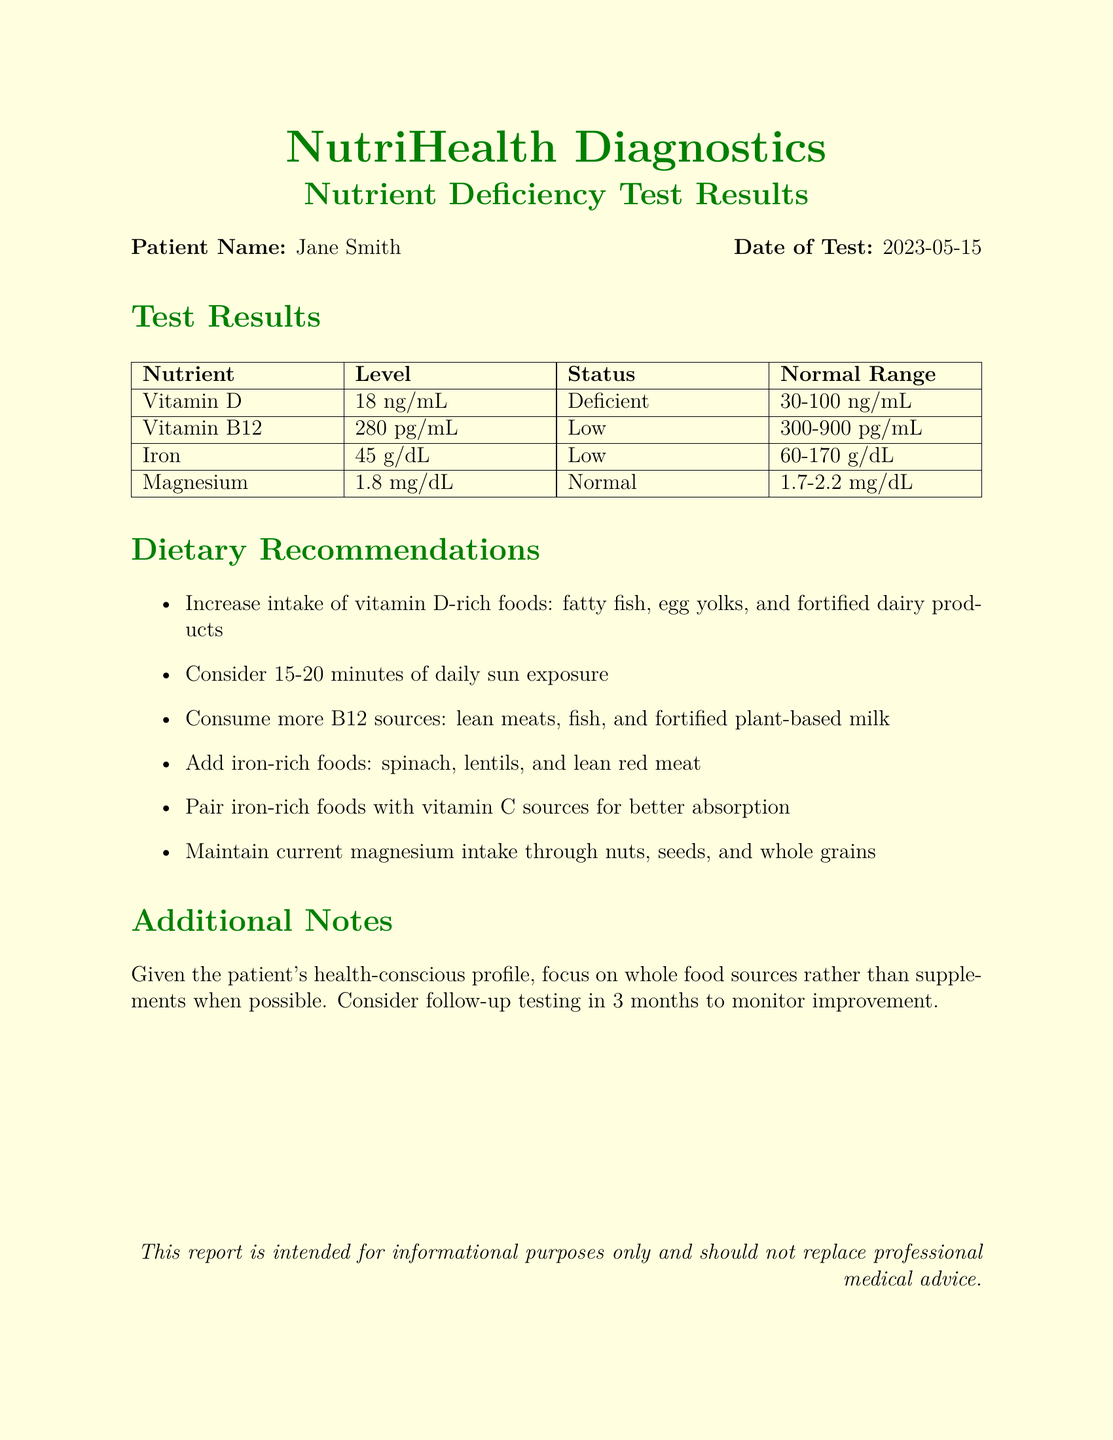What is the patient's name? The patient's name is provided in the document's header.
Answer: Jane Smith What is the date of the test? The date of the test is mentioned in the document's header alongside the patient's name.
Answer: 2023-05-15 What is the level of Vitamin D? The level of Vitamin D is listed in the test results table.
Answer: 18 ng/mL What is the status of Iron? The status of Iron is indicated in the test results table next to its level.
Answer: Low Which food is recommended for increasing Vitamin D intake? The dietary recommendations section lists foods that are high in Vitamin D.
Answer: Fatty fish How should iron-rich foods be consumed for better absorption? The document advises pairing iron-rich foods with specific vitamin sources for enhanced absorption.
Answer: With vitamin C sources What is the normal range for Vitamin B12? The normal range for Vitamin B12 is provided in the test results table.
Answer: 300-900 pg/mL What should the patient consider for Vitamin D? The recommendations include lifestyle changes as well as dietary adjustments.
Answer: 15-20 minutes of daily sun exposure What is the recommendation for magnesium intake? The dietary recommendations suggest maintaining the current intake level of this nutrient.
Answer: Maintain current magnesium intake 